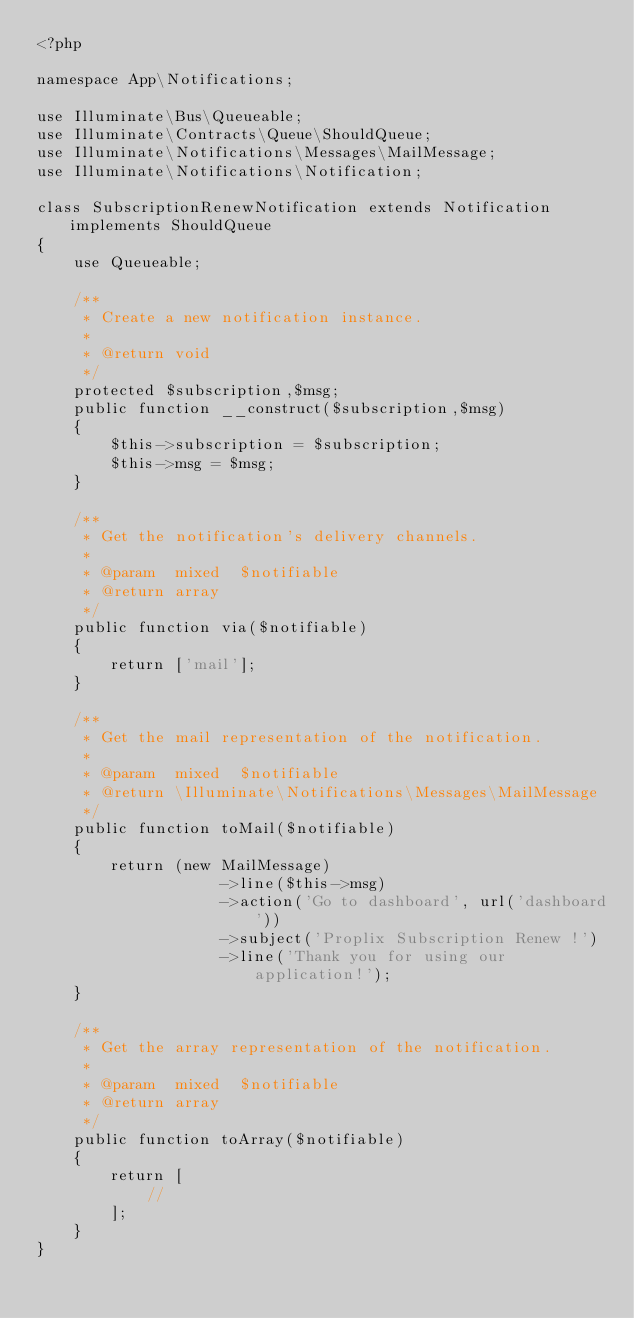<code> <loc_0><loc_0><loc_500><loc_500><_PHP_><?php

namespace App\Notifications;

use Illuminate\Bus\Queueable;
use Illuminate\Contracts\Queue\ShouldQueue;
use Illuminate\Notifications\Messages\MailMessage;
use Illuminate\Notifications\Notification;

class SubscriptionRenewNotification extends Notification implements ShouldQueue
{
    use Queueable;

    /**
     * Create a new notification instance.
     *
     * @return void
     */
    protected $subscription,$msg;
    public function __construct($subscription,$msg)
    {
        $this->subscription = $subscription;
        $this->msg = $msg;
    }

    /**
     * Get the notification's delivery channels.
     *
     * @param  mixed  $notifiable
     * @return array
     */
    public function via($notifiable)
    {
        return ['mail'];
    }

    /**
     * Get the mail representation of the notification.
     *
     * @param  mixed  $notifiable
     * @return \Illuminate\Notifications\Messages\MailMessage
     */
    public function toMail($notifiable)
    {
        return (new MailMessage)
                    ->line($this->msg)
                    ->action('Go to dashboard', url('dashboard'))
                    ->subject('Proplix Subscription Renew !')
                    ->line('Thank you for using our application!');
    }

    /**
     * Get the array representation of the notification.
     *
     * @param  mixed  $notifiable
     * @return array
     */
    public function toArray($notifiable)
    {
        return [
            //
        ];
    }
}
</code> 